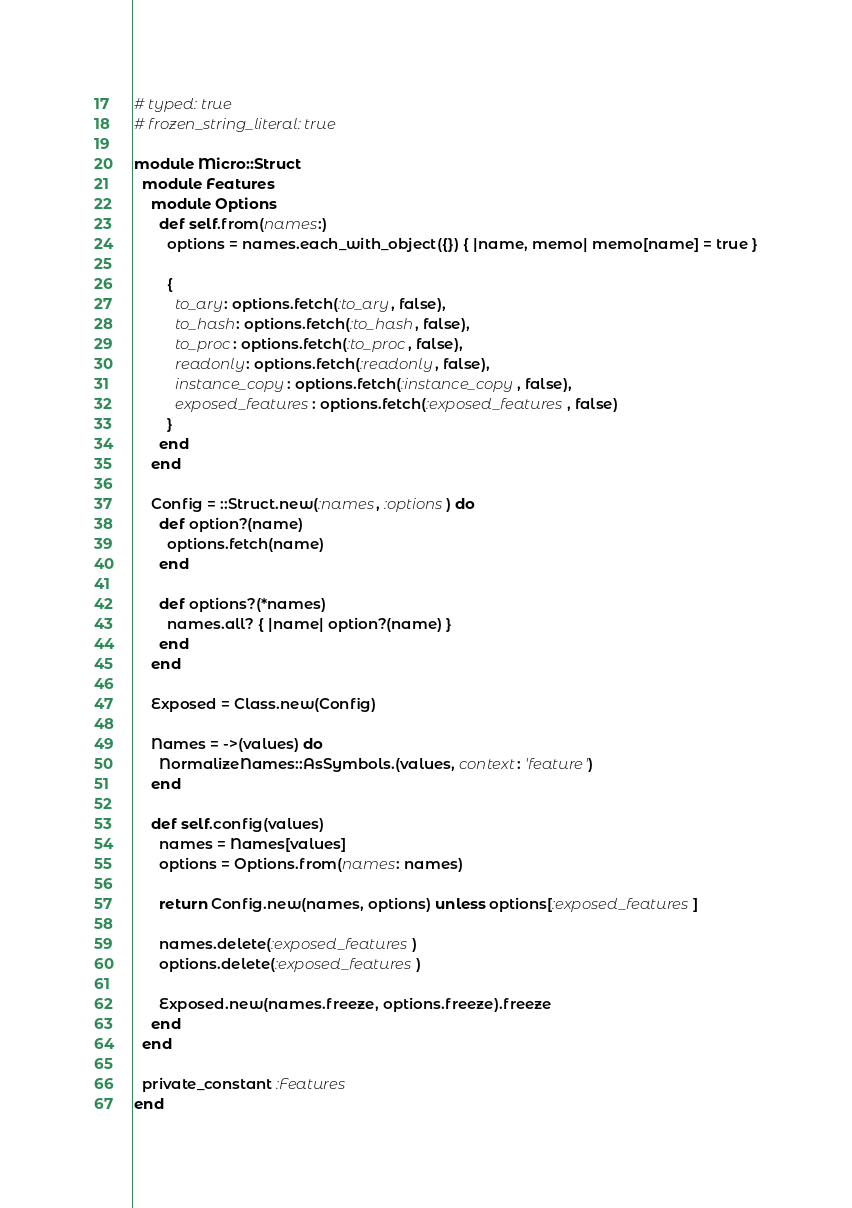Convert code to text. <code><loc_0><loc_0><loc_500><loc_500><_Ruby_># typed: true
# frozen_string_literal: true

module Micro::Struct
  module Features
    module Options
      def self.from(names:)
        options = names.each_with_object({}) { |name, memo| memo[name] = true }

        {
          to_ary: options.fetch(:to_ary, false),
          to_hash: options.fetch(:to_hash, false),
          to_proc: options.fetch(:to_proc, false),
          readonly: options.fetch(:readonly, false),
          instance_copy: options.fetch(:instance_copy, false),
          exposed_features: options.fetch(:exposed_features, false)
        }
      end
    end

    Config = ::Struct.new(:names, :options) do
      def option?(name)
        options.fetch(name)
      end

      def options?(*names)
        names.all? { |name| option?(name) }
      end
    end

    Exposed = Class.new(Config)

    Names = ->(values) do
      NormalizeNames::AsSymbols.(values, context: 'feature')
    end

    def self.config(values)
      names = Names[values]
      options = Options.from(names: names)

      return Config.new(names, options) unless options[:exposed_features]

      names.delete(:exposed_features)
      options.delete(:exposed_features)

      Exposed.new(names.freeze, options.freeze).freeze
    end
  end

  private_constant :Features
end
</code> 